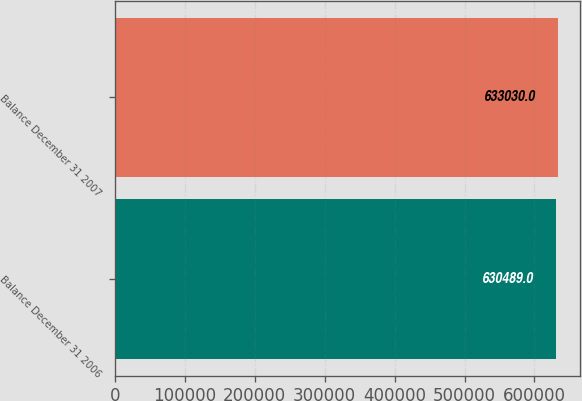Convert chart. <chart><loc_0><loc_0><loc_500><loc_500><bar_chart><fcel>Balance December 31 2006<fcel>Balance December 31 2007<nl><fcel>630489<fcel>633030<nl></chart> 